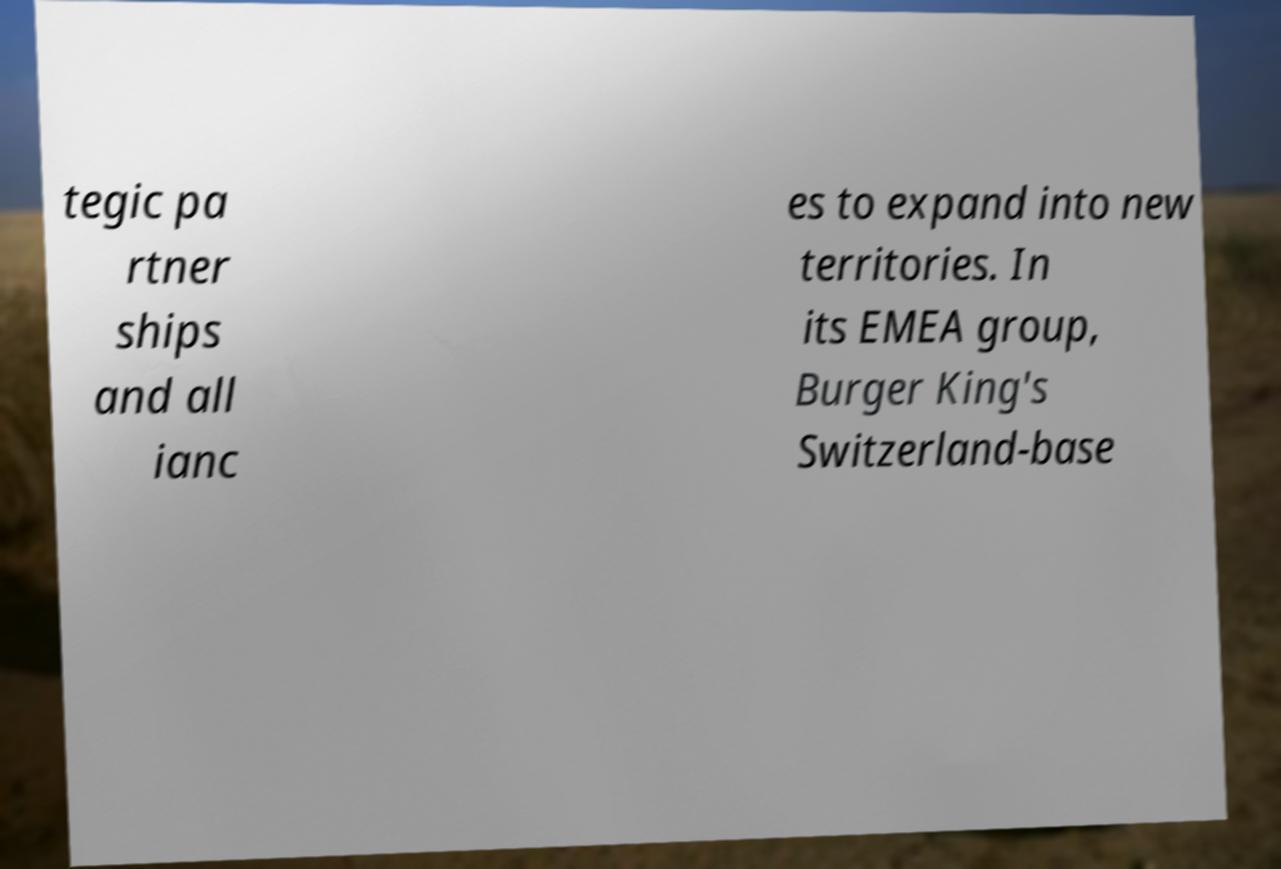Could you assist in decoding the text presented in this image and type it out clearly? tegic pa rtner ships and all ianc es to expand into new territories. In its EMEA group, Burger King's Switzerland-base 